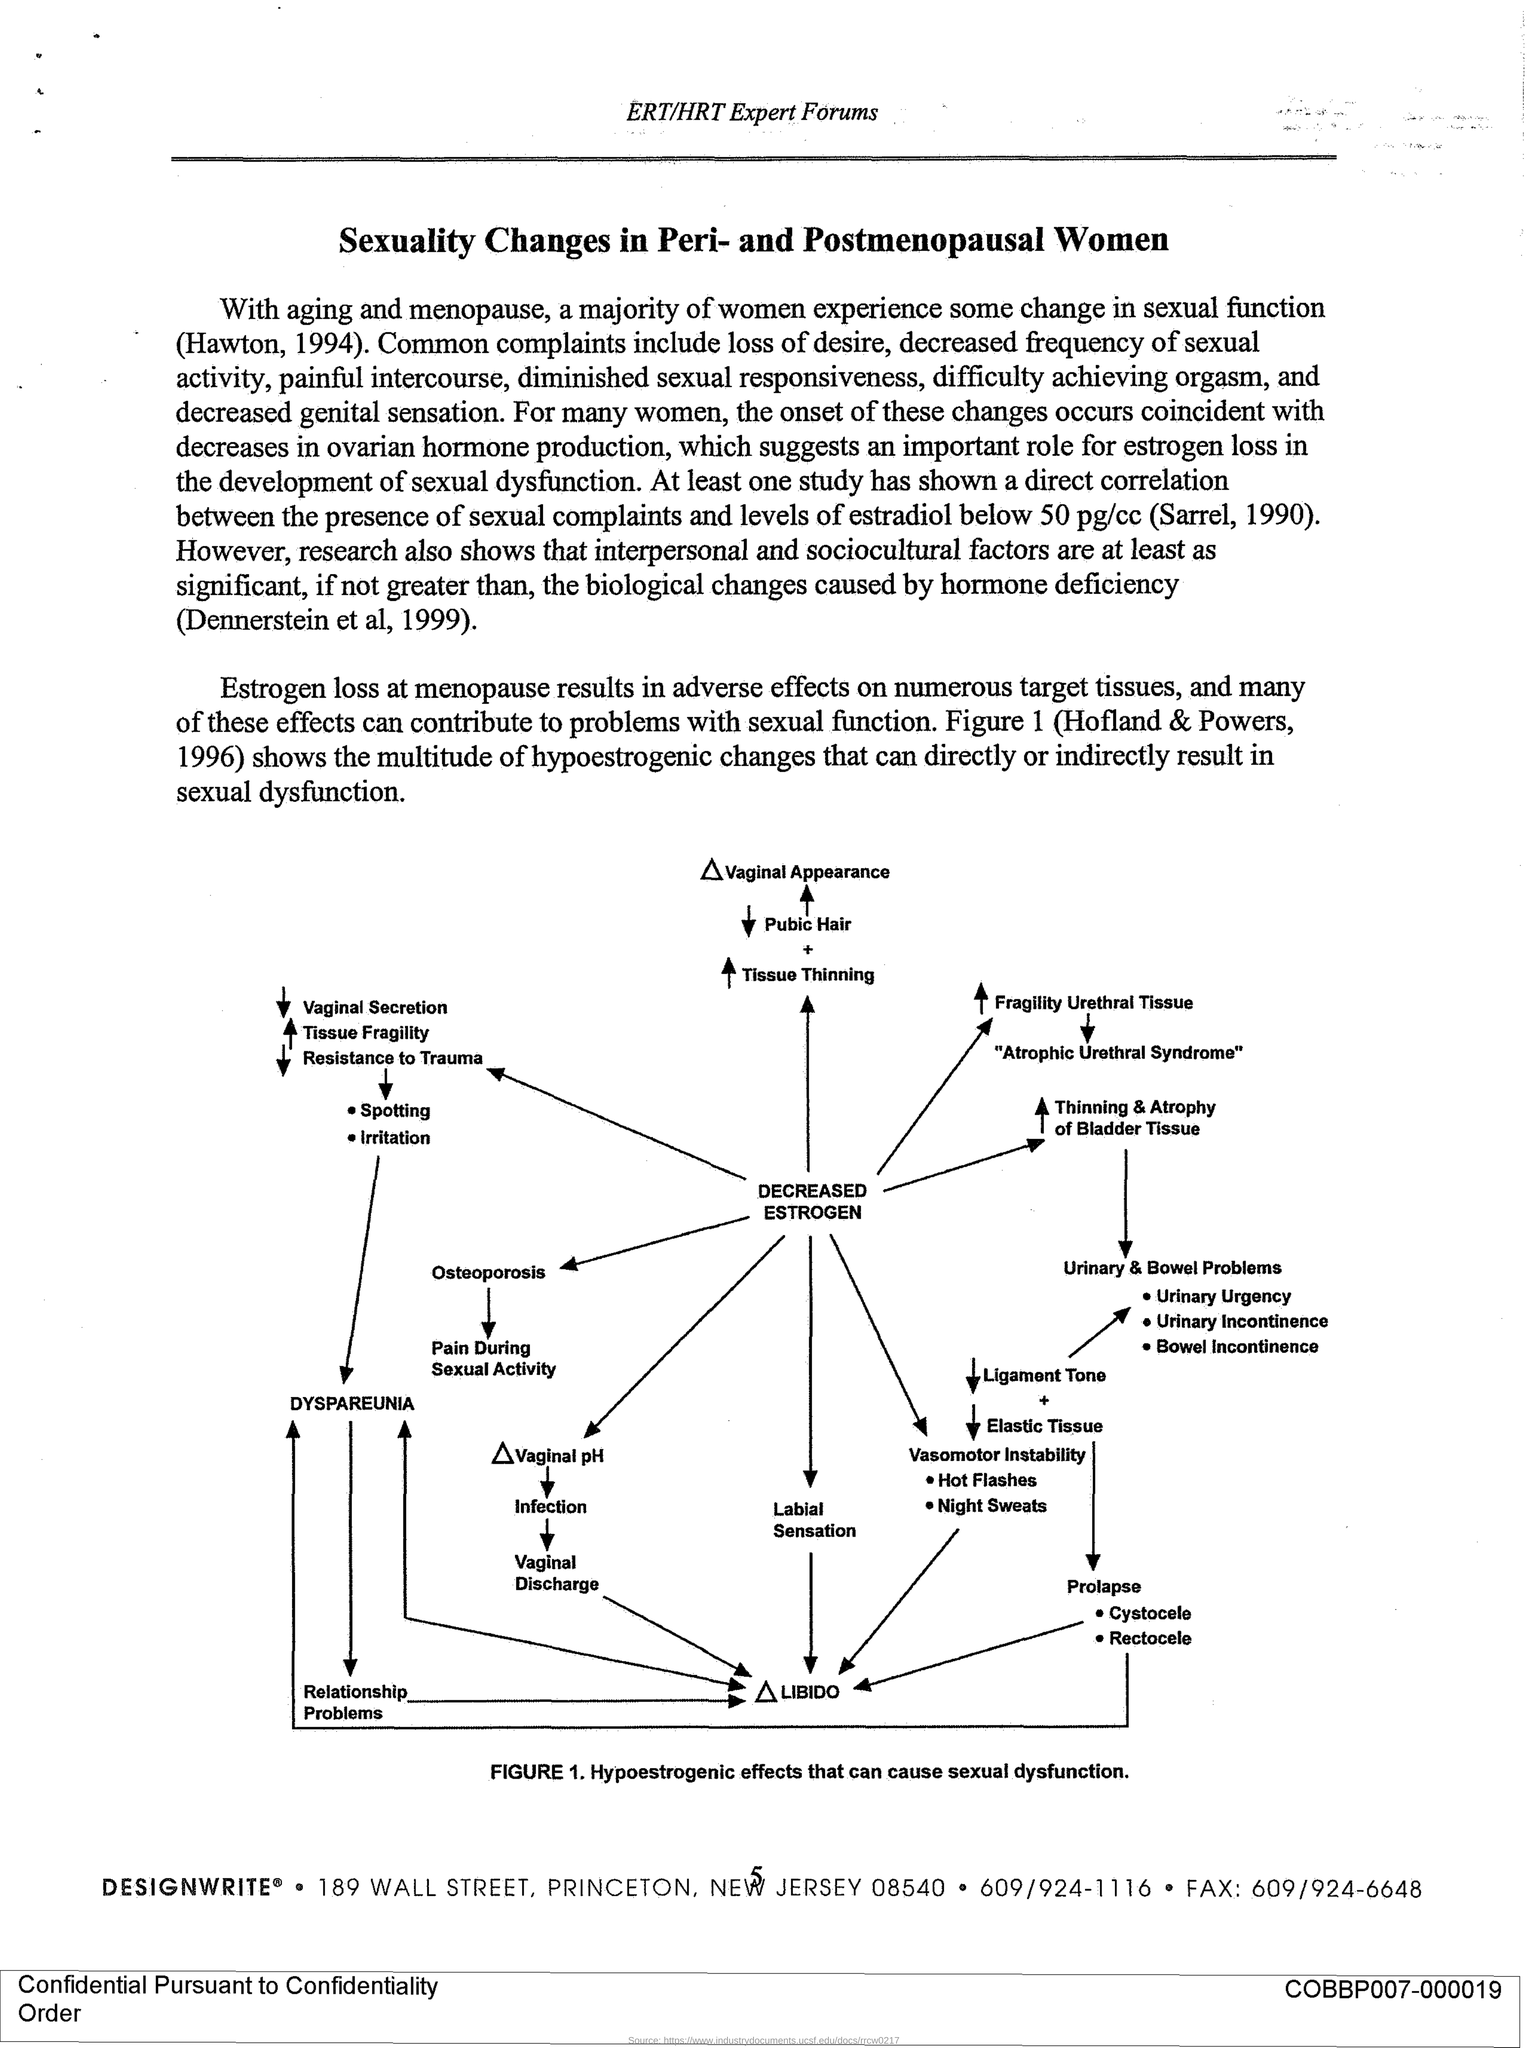What is the ZIP code?
Keep it short and to the point. 08540. What is the Fax number?
Offer a terse response. 609/924-6648. 